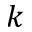<formula> <loc_0><loc_0><loc_500><loc_500>k</formula> 